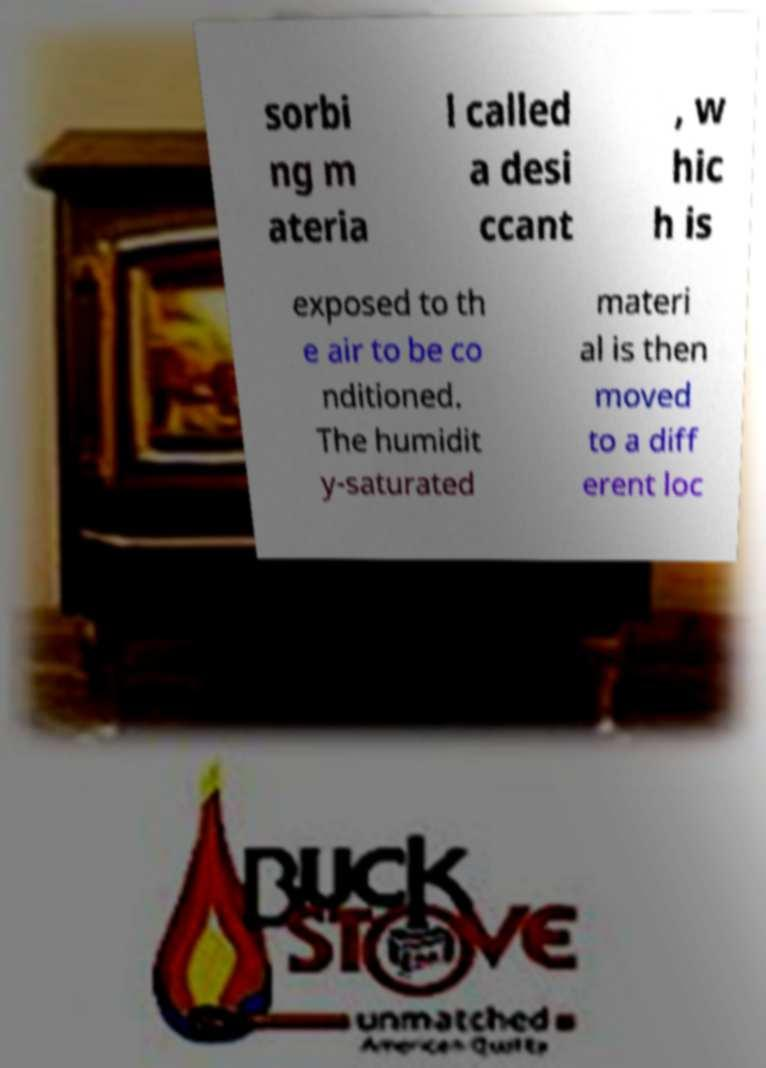Please read and relay the text visible in this image. What does it say? sorbi ng m ateria l called a desi ccant , w hic h is exposed to th e air to be co nditioned. The humidit y-saturated materi al is then moved to a diff erent loc 